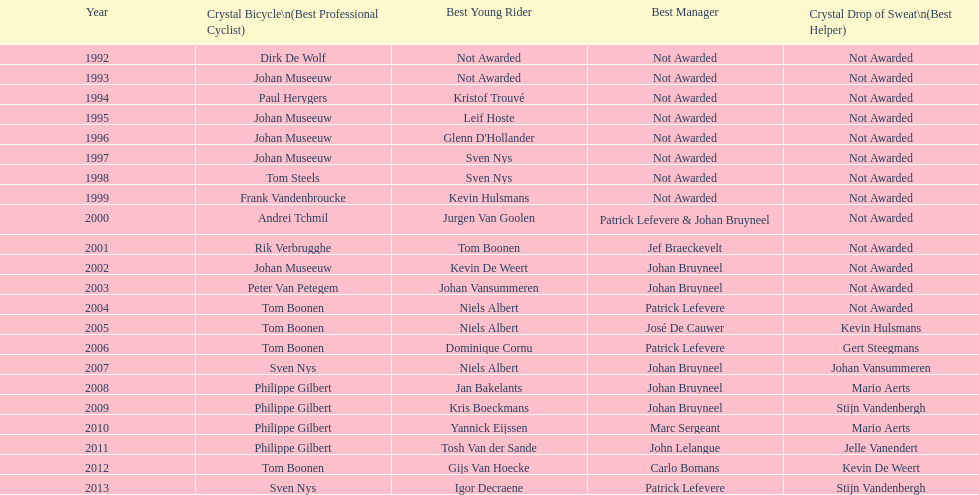Could you help me parse every detail presented in this table? {'header': ['Year', 'Crystal Bicycle\\n(Best Professional Cyclist)', 'Best Young Rider', 'Best Manager', 'Crystal Drop of Sweat\\n(Best Helper)'], 'rows': [['1992', 'Dirk De Wolf', 'Not Awarded', 'Not Awarded', 'Not Awarded'], ['1993', 'Johan Museeuw', 'Not Awarded', 'Not Awarded', 'Not Awarded'], ['1994', 'Paul Herygers', 'Kristof Trouvé', 'Not Awarded', 'Not Awarded'], ['1995', 'Johan Museeuw', 'Leif Hoste', 'Not Awarded', 'Not Awarded'], ['1996', 'Johan Museeuw', "Glenn D'Hollander", 'Not Awarded', 'Not Awarded'], ['1997', 'Johan Museeuw', 'Sven Nys', 'Not Awarded', 'Not Awarded'], ['1998', 'Tom Steels', 'Sven Nys', 'Not Awarded', 'Not Awarded'], ['1999', 'Frank Vandenbroucke', 'Kevin Hulsmans', 'Not Awarded', 'Not Awarded'], ['2000', 'Andrei Tchmil', 'Jurgen Van Goolen', 'Patrick Lefevere & Johan Bruyneel', 'Not Awarded'], ['2001', 'Rik Verbrugghe', 'Tom Boonen', 'Jef Braeckevelt', 'Not Awarded'], ['2002', 'Johan Museeuw', 'Kevin De Weert', 'Johan Bruyneel', 'Not Awarded'], ['2003', 'Peter Van Petegem', 'Johan Vansummeren', 'Johan Bruyneel', 'Not Awarded'], ['2004', 'Tom Boonen', 'Niels Albert', 'Patrick Lefevere', 'Not Awarded'], ['2005', 'Tom Boonen', 'Niels Albert', 'José De Cauwer', 'Kevin Hulsmans'], ['2006', 'Tom Boonen', 'Dominique Cornu', 'Patrick Lefevere', 'Gert Steegmans'], ['2007', 'Sven Nys', 'Niels Albert', 'Johan Bruyneel', 'Johan Vansummeren'], ['2008', 'Philippe Gilbert', 'Jan Bakelants', 'Johan Bruyneel', 'Mario Aerts'], ['2009', 'Philippe Gilbert', 'Kris Boeckmans', 'Johan Bruyneel', 'Stijn Vandenbergh'], ['2010', 'Philippe Gilbert', 'Yannick Eijssen', 'Marc Sergeant', 'Mario Aerts'], ['2011', 'Philippe Gilbert', 'Tosh Van der Sande', 'John Lelangue', 'Jelle Vanendert'], ['2012', 'Tom Boonen', 'Gijs Van Hoecke', 'Carlo Bomans', 'Kevin De Weert'], ['2013', 'Sven Nys', 'Igor Decraene', 'Patrick Lefevere', 'Stijn Vandenbergh']]} Which cyclist has claimed the most best young rider awards? Niels Albert. 